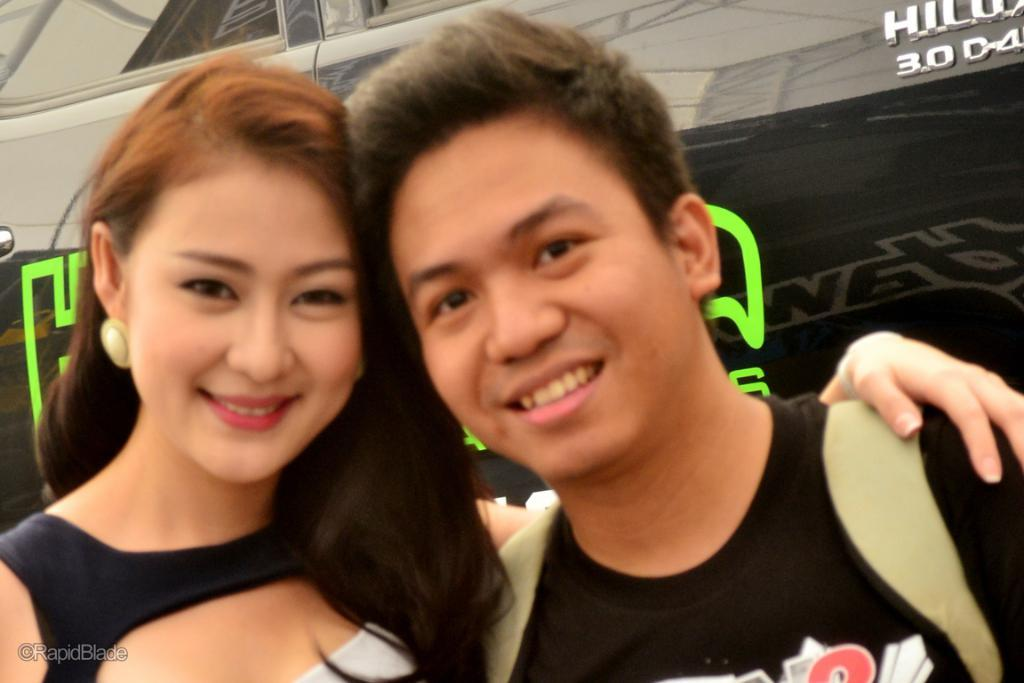How many people are in the image? There are persons in the image, but the exact number cannot be determined from the provided facts. What type of vehicle is in the image? There is a vehicle in the image, but the specific type cannot be determined from the provided facts. What can be observed on the surface of the vehicle? There are reflections on the vehicle. What is written or displayed on the vehicle? There is text on the vehicle. Can you see any insects crawling on the cushion in the image? There is no mention of a cushion in the provided facts, and therefore no insects can be observed on it. 